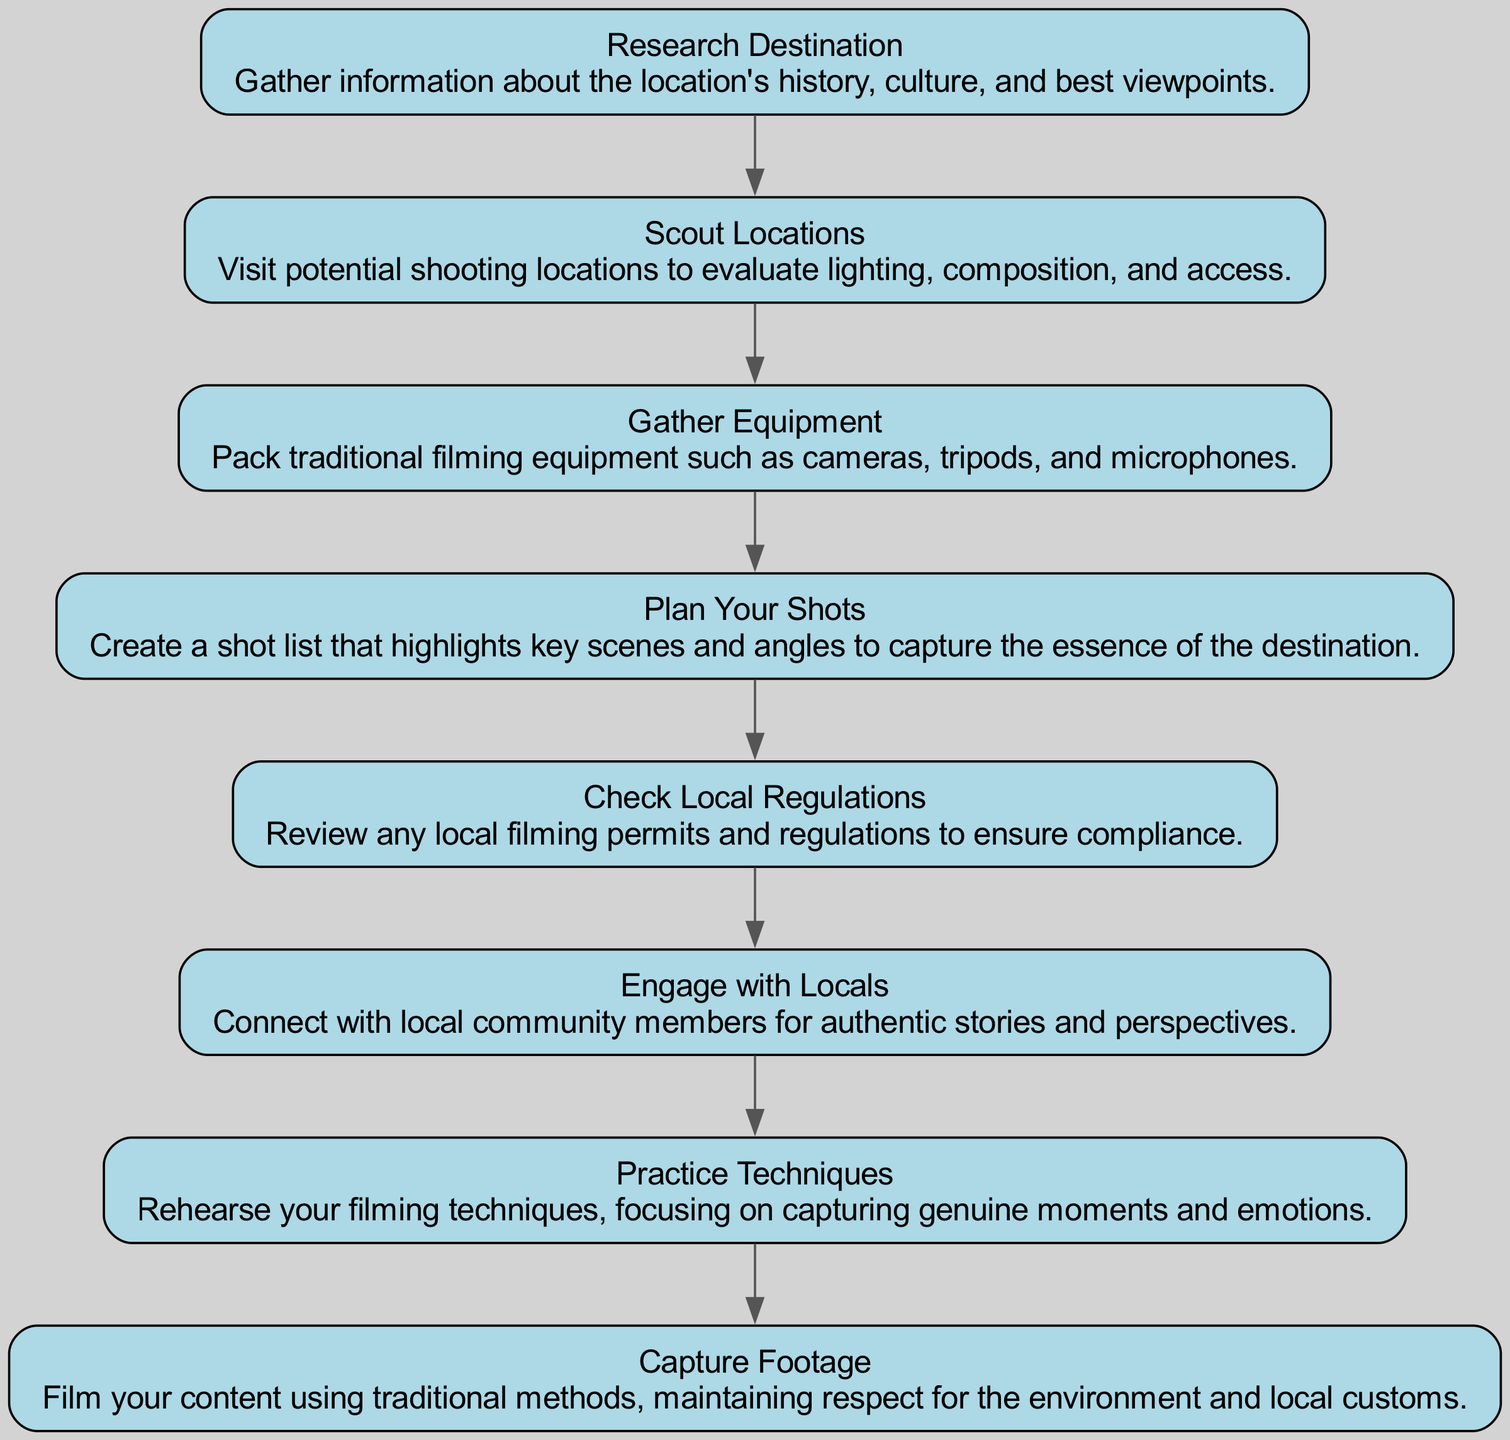What is the first step in the diagram? The first step in the diagram is "Research Destination." It is the initial action listed in the flow and is connected at the top of the diagram, indicating it is the starting point.
Answer: Research Destination How many steps are there in total? There are 8 steps in total as each step listed represents a node in the flowchart. By counting the steps from the beginning to the end of the diagram, we confirm there are eight distinct actions.
Answer: 8 What is the last step in the flowchart? The last step in the flowchart is "Capture Footage." It is positioned at the bottom of the diagram and follows all previous steps, indicating it is the final action to be taken.
Answer: Capture Footage What step comes after "Engage with Locals"? The step that comes after "Engage with Locals" is "Practice Techniques." This can be determined by following the flow from one node to the next in the sequence.
Answer: Practice Techniques Which step involves checking for permits? The step that involves checking for permits is "Check Local Regulations." It emphasizes the importance of compliance before proceeding to film.
Answer: Check Local Regulations How many steps are focused on preparation before filming? There are 6 steps focused on preparation before filming, which includes the first 6 steps before the last action, "Capture Footage." These steps prepare for the act of filming itself.
Answer: 6 Which two steps are essential for connecting with the community? The two essential steps for connecting with the community are "Engage with Locals" and "Research Destination." Each of these actions emphasizes understanding and connecting to the local people and culture.
Answer: Engage with Locals, Research Destination What is the purpose of "Scout Locations"? The purpose of "Scout Locations" is to evaluate lighting, composition, and access for filming. This step is crucial for ensuring the visual quality of the footage.
Answer: Evaluate lighting, composition, and access 